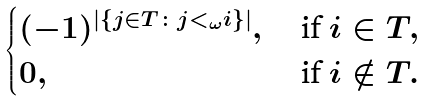<formula> <loc_0><loc_0><loc_500><loc_500>\begin{cases} ( - 1 ) ^ { | \{ j \in T \colon j < _ { \omega } i \} | } , \ & \text {if} \ i \in T , \\ 0 , & \text {if} \ i \notin T . \end{cases}</formula> 